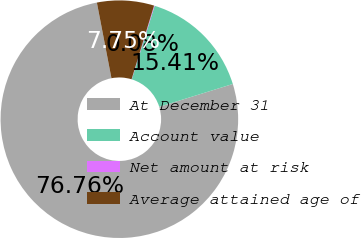Convert chart to OTSL. <chart><loc_0><loc_0><loc_500><loc_500><pie_chart><fcel>At December 31<fcel>Account value<fcel>Net amount at risk<fcel>Average attained age of<nl><fcel>76.76%<fcel>15.41%<fcel>0.08%<fcel>7.75%<nl></chart> 